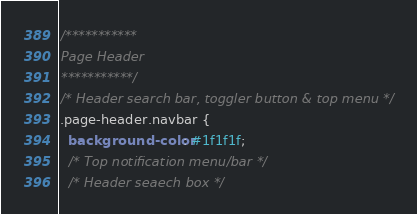Convert code to text. <code><loc_0><loc_0><loc_500><loc_500><_CSS_>/*********** 
Page Header
***********/
/* Header search bar, toggler button & top menu */
.page-header.navbar {
  background-color: #1f1f1f;
  /* Top notification menu/bar */
  /* Header seaech box */</code> 